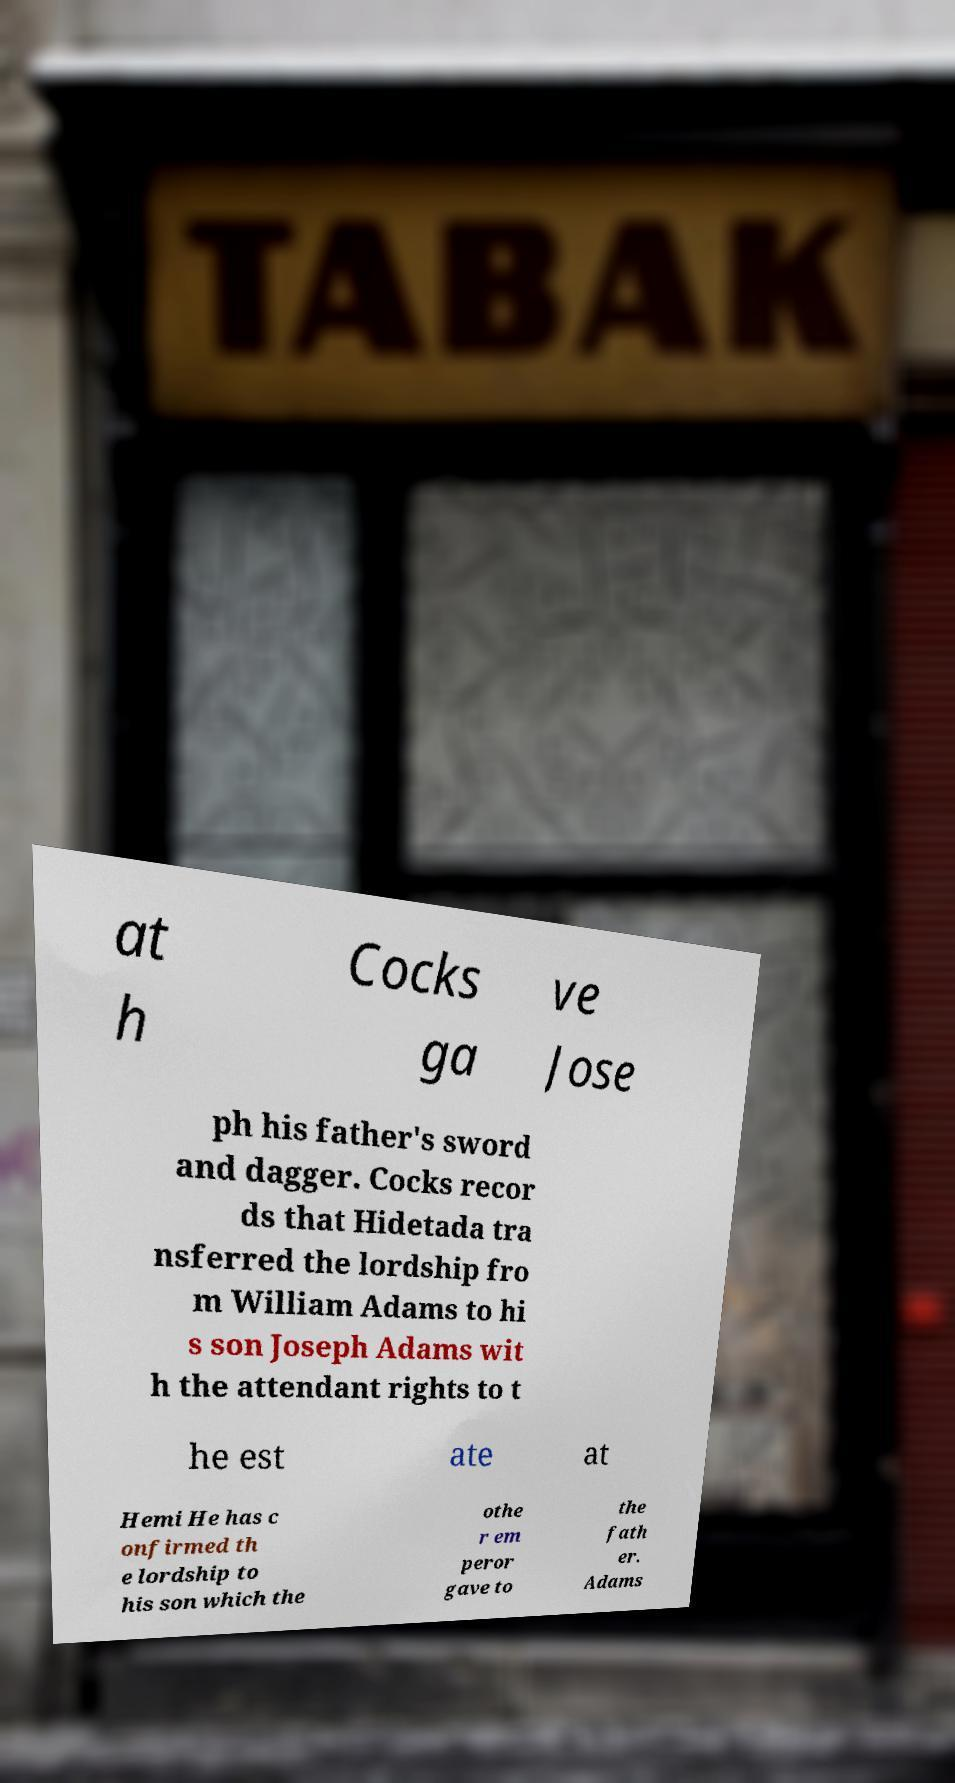I need the written content from this picture converted into text. Can you do that? at h Cocks ga ve Jose ph his father's sword and dagger. Cocks recor ds that Hidetada tra nsferred the lordship fro m William Adams to hi s son Joseph Adams wit h the attendant rights to t he est ate at Hemi He has c onfirmed th e lordship to his son which the othe r em peror gave to the fath er. Adams 